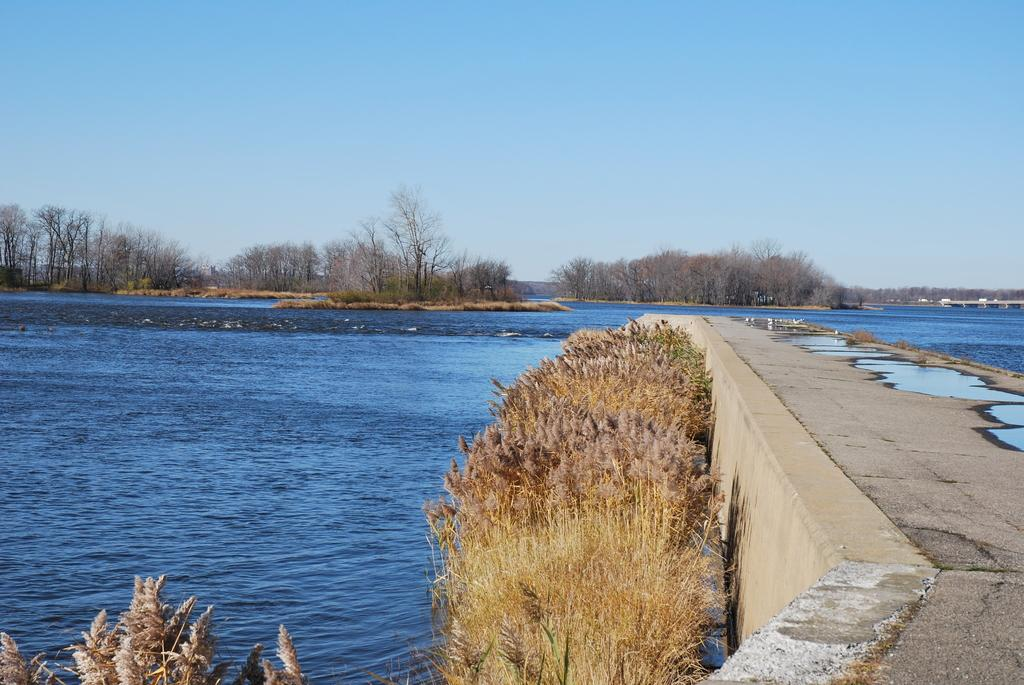What type of plants can be seen in the image? There are dry plants in the image. What can be used for walking in the image? There is a small walking area for walking in the image. What is the color and condition of the water in the image? The water is blue and clear in the image. What type of vegetation is in the background of the image? There are dry trees in the background of the image. What is the condition of the sky in the image? The sky is blue and clear in the image. What type of pie is being served at the work event in the image? There is no work event or pie present in the image. What is the need for the dry plants in the image? The image does not indicate any specific need for the dry plants; they are simply a part of the scene. 